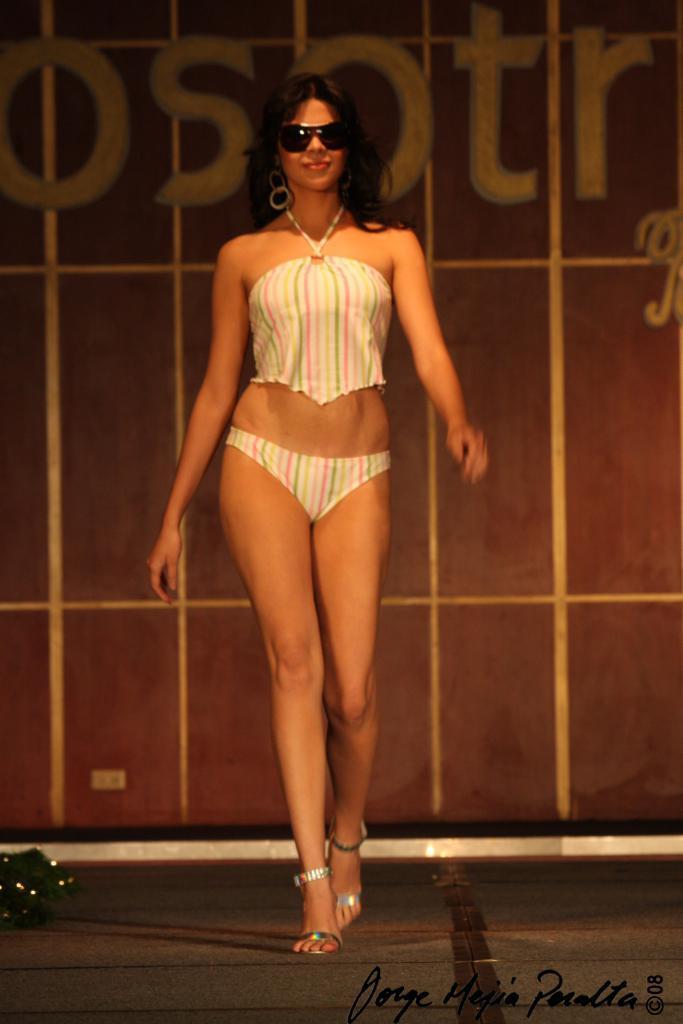Could you give a brief overview of what you see in this image? In this image, there is a person wearing clothes and walking on the floor. 